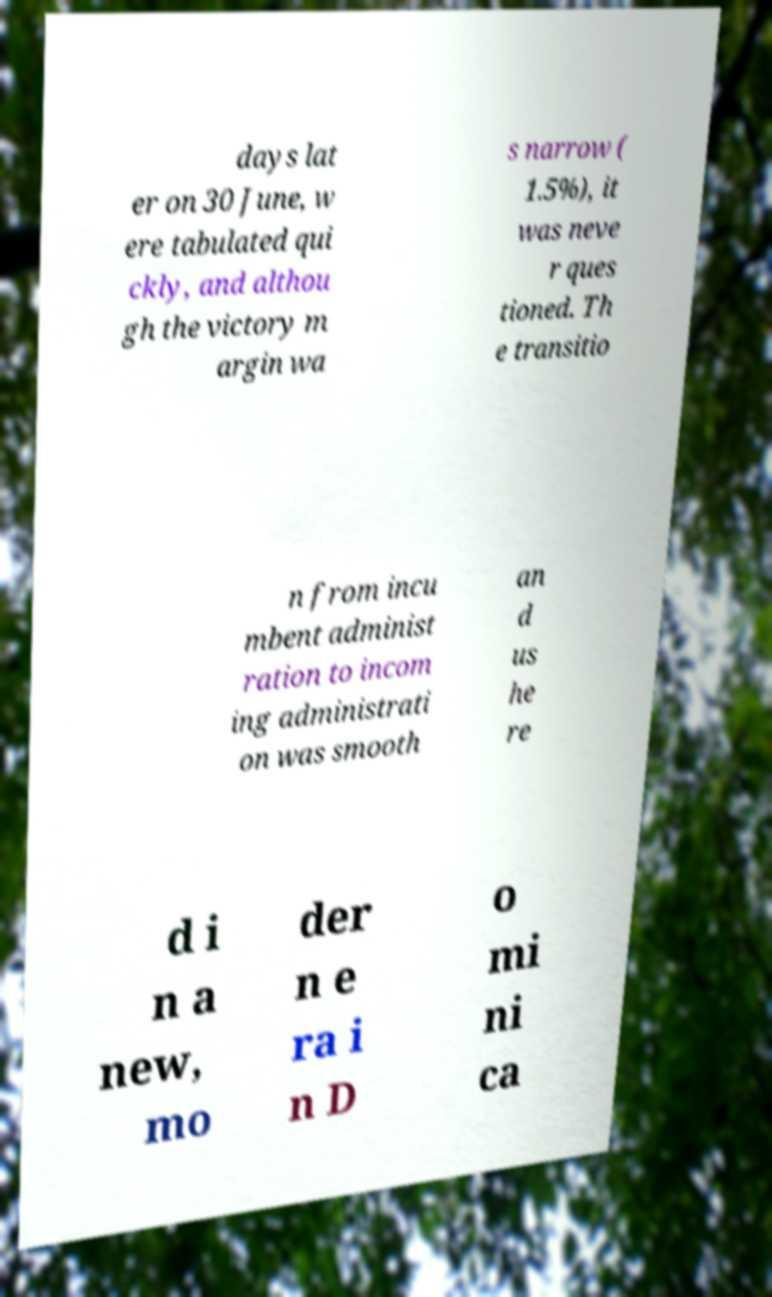There's text embedded in this image that I need extracted. Can you transcribe it verbatim? days lat er on 30 June, w ere tabulated qui ckly, and althou gh the victory m argin wa s narrow ( 1.5%), it was neve r ques tioned. Th e transitio n from incu mbent administ ration to incom ing administrati on was smooth an d us he re d i n a new, mo der n e ra i n D o mi ni ca 